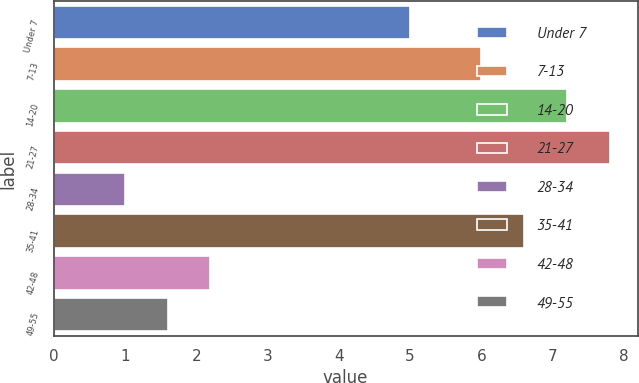<chart> <loc_0><loc_0><loc_500><loc_500><bar_chart><fcel>Under 7<fcel>7-13<fcel>14-20<fcel>21-27<fcel>28-34<fcel>35-41<fcel>42-48<fcel>49-55<nl><fcel>5<fcel>6<fcel>7.2<fcel>7.8<fcel>1<fcel>6.6<fcel>2.2<fcel>1.6<nl></chart> 